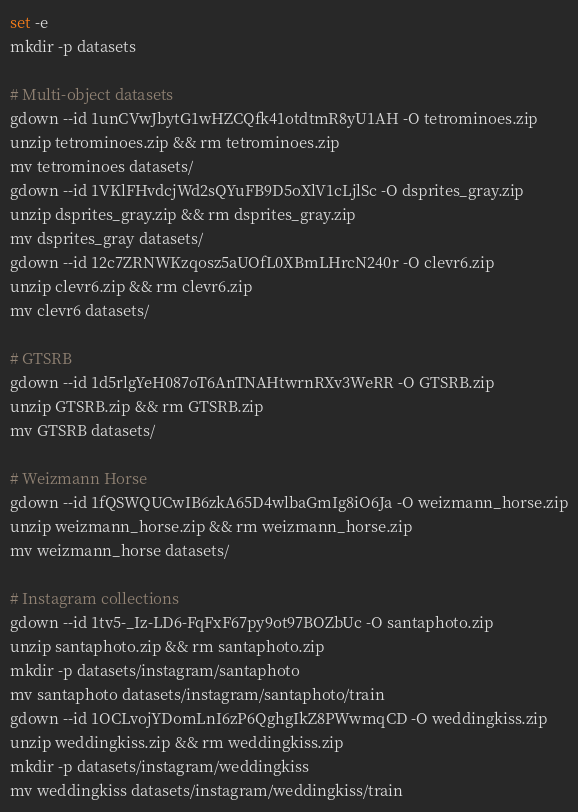Convert code to text. <code><loc_0><loc_0><loc_500><loc_500><_Bash_>set -e
mkdir -p datasets

# Multi-object datasets
gdown --id 1unCVwJbytG1wHZCQfk41otdtmR8yU1AH -O tetrominoes.zip
unzip tetrominoes.zip && rm tetrominoes.zip
mv tetrominoes datasets/
gdown --id 1VKlFHvdcjWd2sQYuFB9D5oXlV1cLjlSc -O dsprites_gray.zip
unzip dsprites_gray.zip && rm dsprites_gray.zip
mv dsprites_gray datasets/
gdown --id 12c7ZRNWKzqosz5aUOfL0XBmLHrcN240r -O clevr6.zip
unzip clevr6.zip && rm clevr6.zip
mv clevr6 datasets/

# GTSRB
gdown --id 1d5rlgYeH087oT6AnTNAHtwrnRXv3WeRR -O GTSRB.zip
unzip GTSRB.zip && rm GTSRB.zip
mv GTSRB datasets/

# Weizmann Horse
gdown --id 1fQSWQUCwIB6zkA65D4wlbaGmIg8iO6Ja -O weizmann_horse.zip
unzip weizmann_horse.zip && rm weizmann_horse.zip
mv weizmann_horse datasets/

# Instagram collections
gdown --id 1tv5-_Iz-LD6-FqFxF67py9ot97BOZbUc -O santaphoto.zip
unzip santaphoto.zip && rm santaphoto.zip
mkdir -p datasets/instagram/santaphoto
mv santaphoto datasets/instagram/santaphoto/train
gdown --id 1OCLvojYDomLnI6zP6QghgIkZ8PWwmqCD -O weddingkiss.zip
unzip weddingkiss.zip && rm weddingkiss.zip
mkdir -p datasets/instagram/weddingkiss
mv weddingkiss datasets/instagram/weddingkiss/train
</code> 